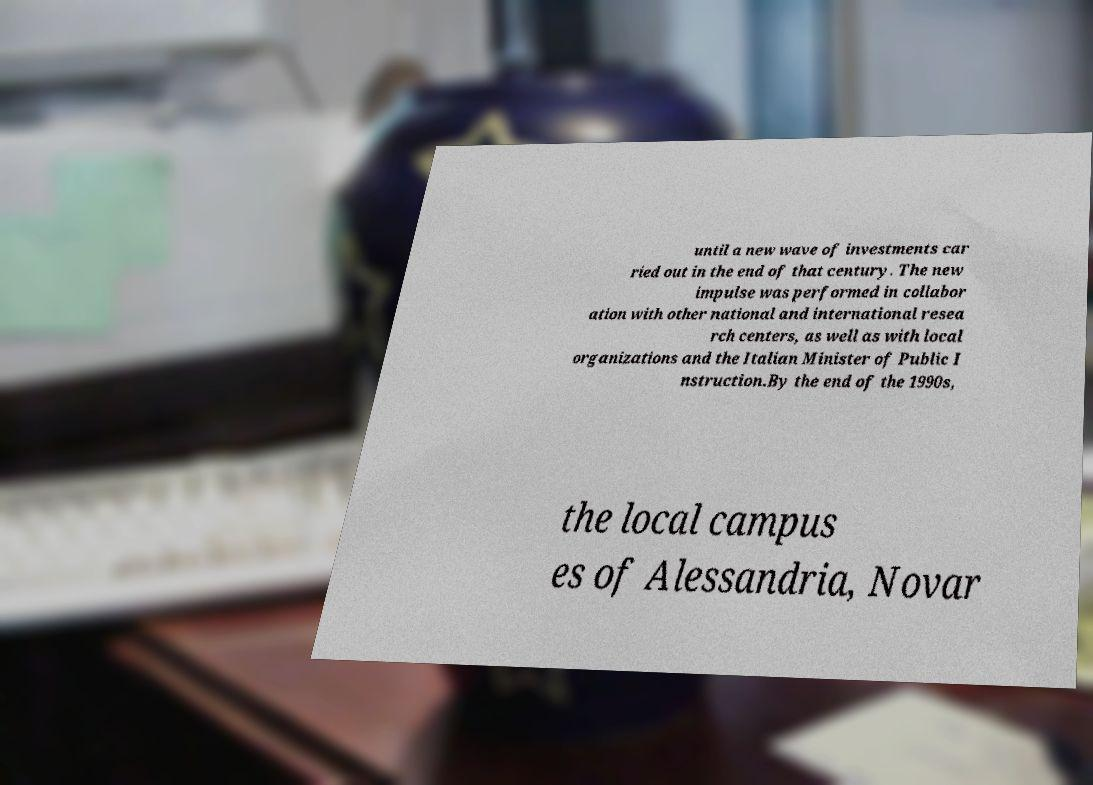What messages or text are displayed in this image? I need them in a readable, typed format. until a new wave of investments car ried out in the end of that century. The new impulse was performed in collabor ation with other national and international resea rch centers, as well as with local organizations and the Italian Minister of Public I nstruction.By the end of the 1990s, the local campus es of Alessandria, Novar 